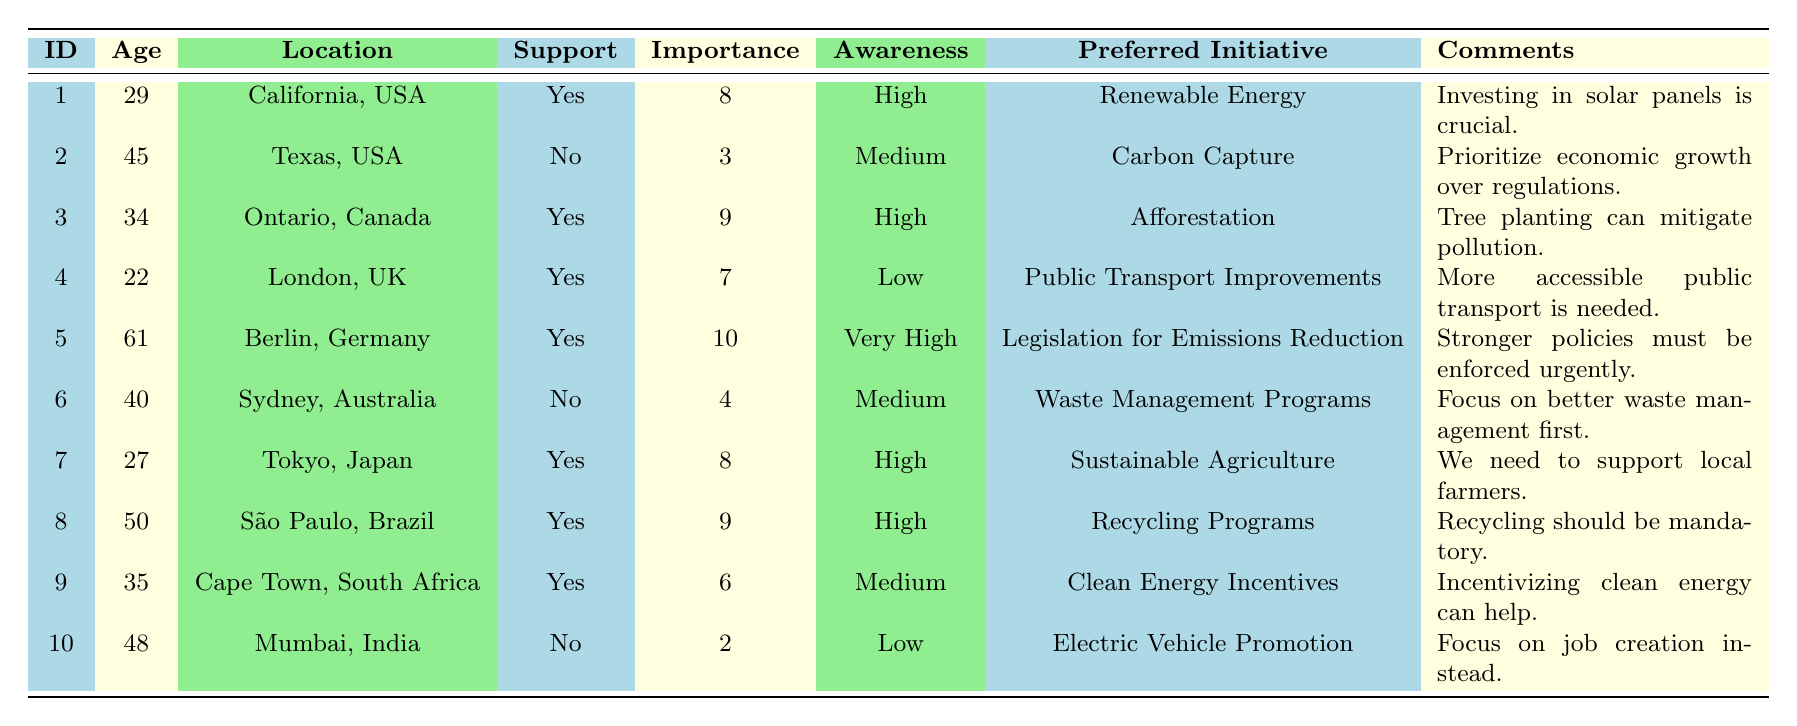What's the total number of respondents who support climate initiatives? There are 7 respondents who have indicated they support climate initiatives (respondent IDs 1, 3, 4, 5, 7, 8, and 9).
Answer: 7 What is the average importance rating among respondents who do not support climate initiatives? There are 3 respondents who do not support climate initiatives, with ratings of 3, 4, and 2. The sum is (3 + 4 + 2) = 9, and there are 3 data points, so the average is 9/3 = 3.
Answer: 3 Which location has the respondent with the highest importance rating? Respondent ID 5 from Berlin, Germany has the highest importance rating of 10.
Answer: Berlin, Germany Do any respondents from Australia support climate initiatives? No, the respondent from Australia (respondent ID 6) does not support climate initiatives.
Answer: No What is the most preferred initiative type among those who rated its importance as 10? Only one respondent (ID 5) rated the importance as 10, and their preferred initiative type is "Legislation for Emissions Reduction."
Answer: Legislation for Emissions Reduction How many respondents have a high awareness of climate initiatives? There are 4 respondents who have a high awareness (respondent IDs 1, 3, 7, and 8).
Answer: 4 What percentage of respondents aged 40 and above support climate initiatives? There are 4 respondents aged 40 and above (IDs 5, 6, and 10). Only IDs 5 and 6 support, which gives a support percentage of (2/4) * 100 = 50%.
Answer: 50% What initiative type is preferred by the respondent from Tokyo? The respondent from Tokyo (ID 7) prefers "Sustainable Agriculture."
Answer: Sustainable Agriculture How many respondents commented on the need for stronger policies? Only one respondent (ID 5) commented on the need for stronger policies, indicating urgency.
Answer: 1 Which age group has the highest average importance rating among those who support climate initiatives? The ages of respondents who support climate initiatives are 29, 34, 22, 61, 27, 50, and 35. Their respective importance ratings are 8, 9, 7, 10, 8, 9, and 6. The average is (8 + 9 + 7 + 10 + 8 + 9 + 6) / 7 = 57 / 7 = 8.14, confirming the highest average but does not correlate with a specific age group category directly.
Answer: 8.14 (Not specific to an age group) What is the relationship between support for climate initiatives and awareness levels as derived from the data? Among the 10 respondents, those with "High" awareness support climate initiatives, while those with "Low" awareness don't adequately support them at all (e.g., IDs 2 and 10). This indicates that higher awareness correlates with support.
Answer: Higher awareness relates to support for climate initiatives 